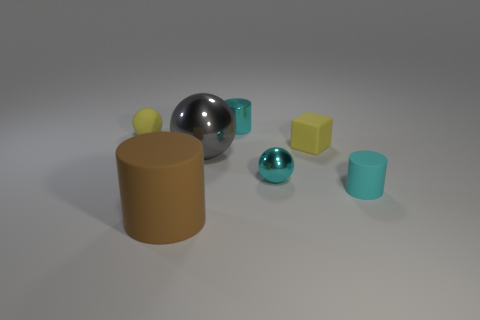Add 3 big gray metallic balls. How many objects exist? 10 Subtract all balls. How many objects are left? 4 Add 6 tiny purple rubber balls. How many tiny purple rubber balls exist? 6 Subtract 0 brown balls. How many objects are left? 7 Subtract all cyan metal balls. Subtract all brown cylinders. How many objects are left? 5 Add 1 big matte cylinders. How many big matte cylinders are left? 2 